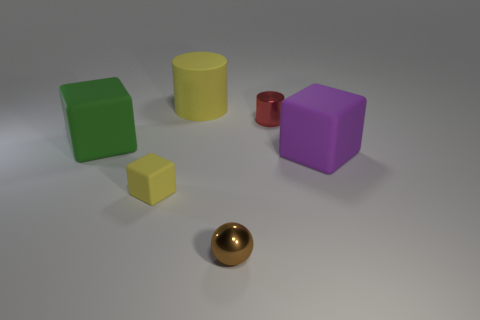Subtract all big rubber cubes. How many cubes are left? 1 Add 3 tiny spheres. How many objects exist? 9 Subtract all cylinders. How many objects are left? 4 Add 1 red blocks. How many red blocks exist? 1 Subtract 0 purple cylinders. How many objects are left? 6 Subtract all brown cylinders. Subtract all cyan blocks. How many cylinders are left? 2 Subtract all brown objects. Subtract all tiny matte blocks. How many objects are left? 4 Add 5 big rubber cylinders. How many big rubber cylinders are left? 6 